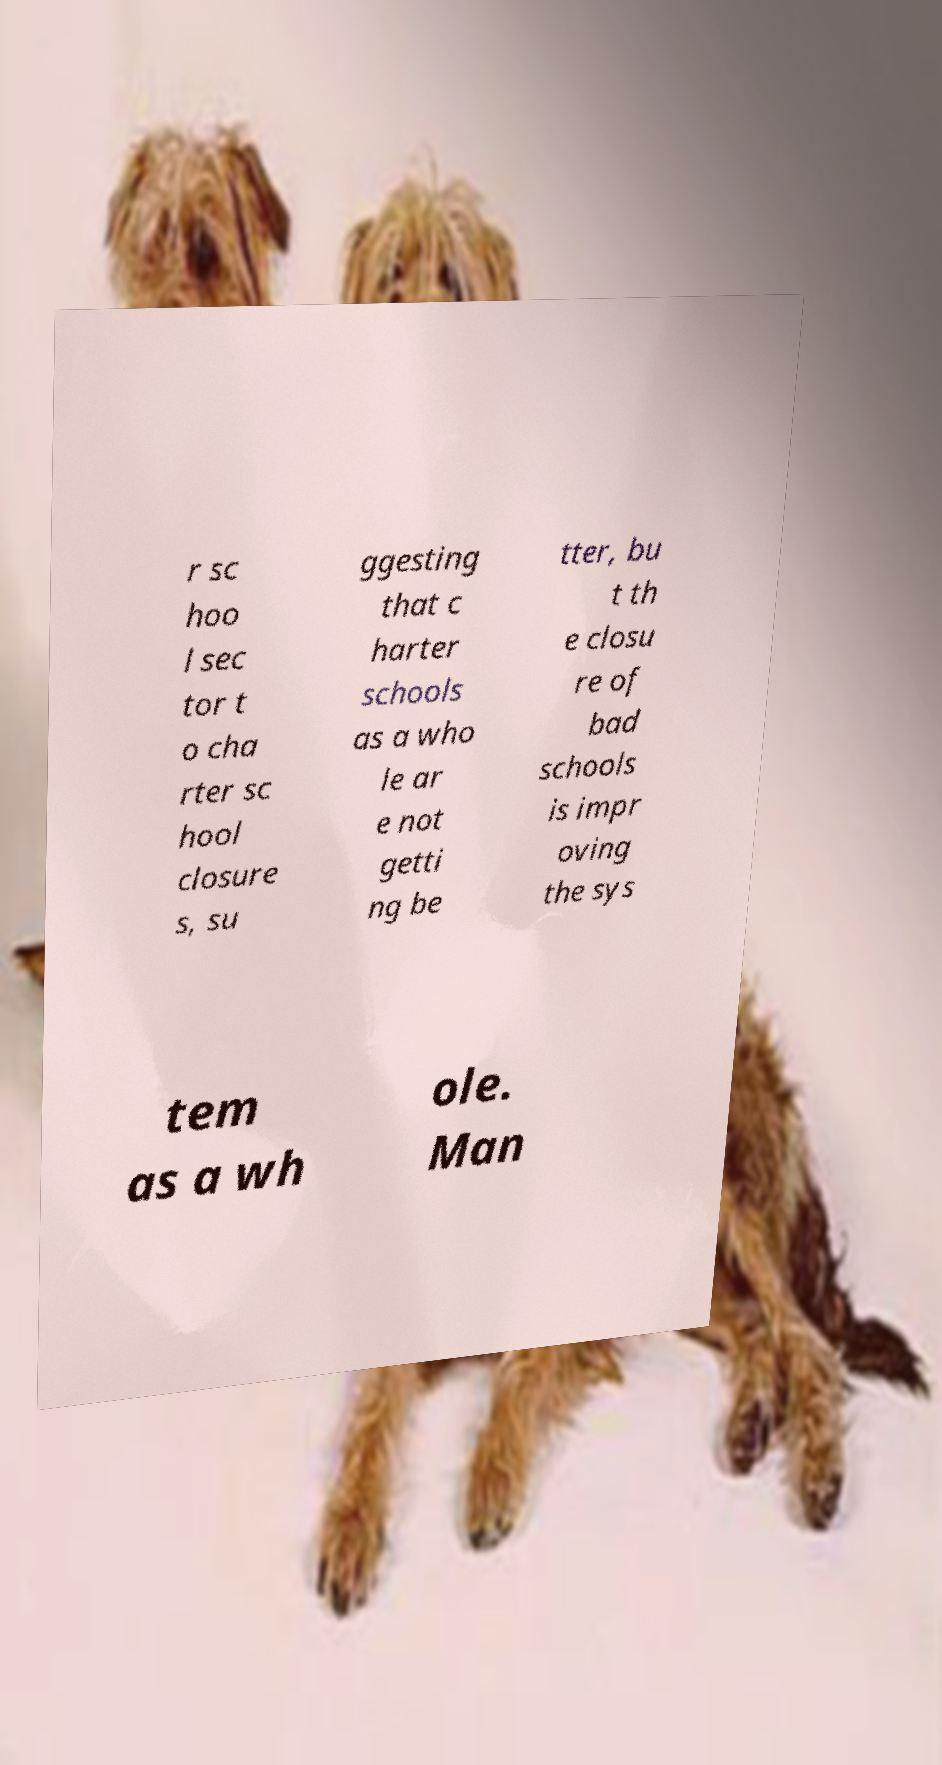Please identify and transcribe the text found in this image. r sc hoo l sec tor t o cha rter sc hool closure s, su ggesting that c harter schools as a who le ar e not getti ng be tter, bu t th e closu re of bad schools is impr oving the sys tem as a wh ole. Man 